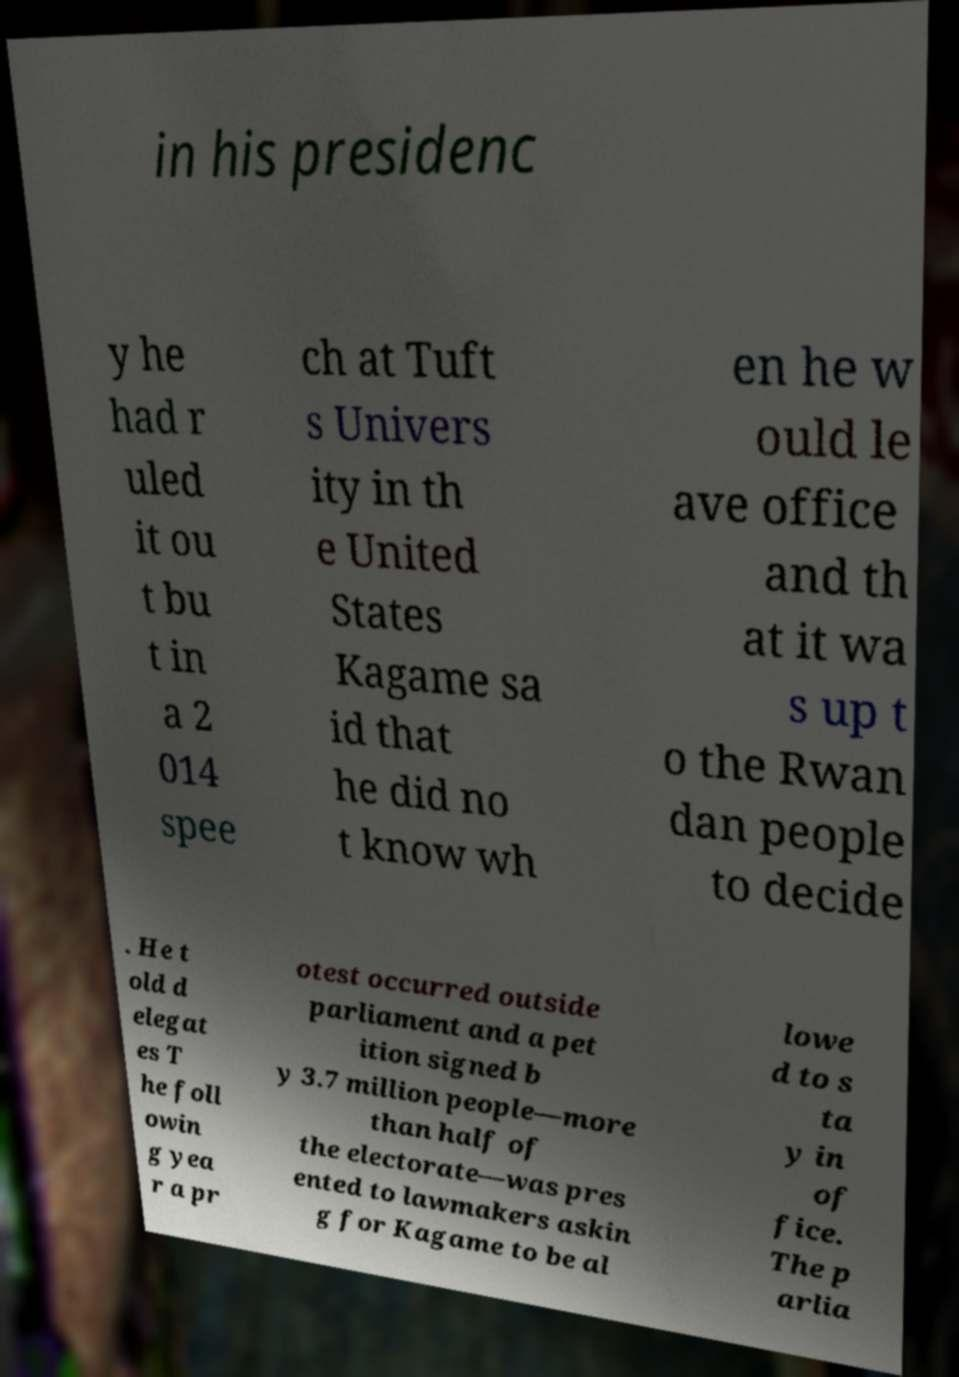Could you assist in decoding the text presented in this image and type it out clearly? in his presidenc y he had r uled it ou t bu t in a 2 014 spee ch at Tuft s Univers ity in th e United States Kagame sa id that he did no t know wh en he w ould le ave office and th at it wa s up t o the Rwan dan people to decide . He t old d elegat es T he foll owin g yea r a pr otest occurred outside parliament and a pet ition signed b y 3.7 million people—more than half of the electorate—was pres ented to lawmakers askin g for Kagame to be al lowe d to s ta y in of fice. The p arlia 